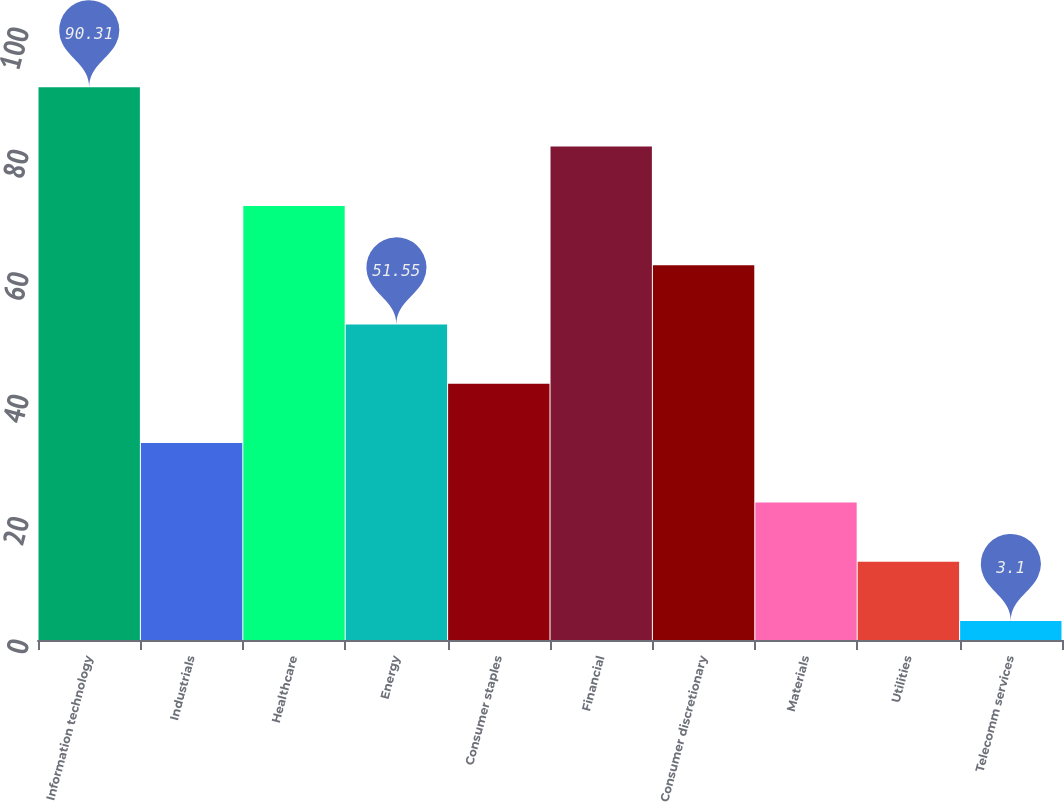Convert chart to OTSL. <chart><loc_0><loc_0><loc_500><loc_500><bar_chart><fcel>Information technology<fcel>Industrials<fcel>Healthcare<fcel>Energy<fcel>Consumer staples<fcel>Financial<fcel>Consumer discretionary<fcel>Materials<fcel>Utilities<fcel>Telecomm services<nl><fcel>90.31<fcel>32.17<fcel>70.93<fcel>51.55<fcel>41.86<fcel>80.62<fcel>61.24<fcel>22.48<fcel>12.79<fcel>3.1<nl></chart> 